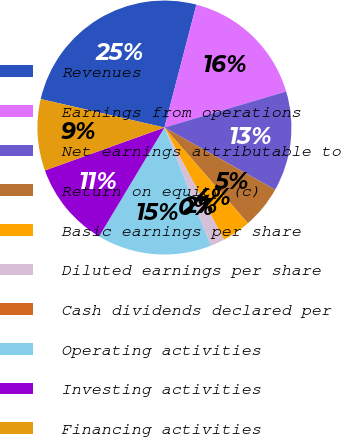Convert chart to OTSL. <chart><loc_0><loc_0><loc_500><loc_500><pie_chart><fcel>Revenues<fcel>Earnings from operations<fcel>Net earnings attributable to<fcel>Return on equity (c)<fcel>Basic earnings per share<fcel>Diluted earnings per share<fcel>Cash dividends declared per<fcel>Operating activities<fcel>Investing activities<fcel>Financing activities<nl><fcel>25.45%<fcel>16.36%<fcel>12.73%<fcel>5.45%<fcel>3.64%<fcel>1.82%<fcel>0.0%<fcel>14.55%<fcel>10.91%<fcel>9.09%<nl></chart> 